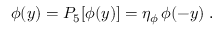<formula> <loc_0><loc_0><loc_500><loc_500>\phi ( y ) = P _ { 5 } [ \phi ( y ) ] = \eta _ { \phi } \, \phi ( - y ) \, .</formula> 